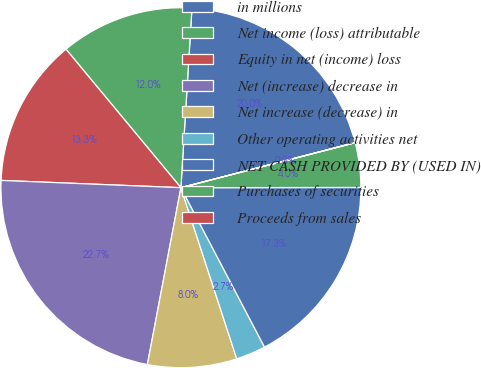<chart> <loc_0><loc_0><loc_500><loc_500><pie_chart><fcel>in millions<fcel>Net income (loss) attributable<fcel>Equity in net (income) loss<fcel>Net (increase) decrease in<fcel>Net increase (decrease) in<fcel>Other operating activities net<fcel>NET CASH PROVIDED BY (USED IN)<fcel>Purchases of securities<fcel>Proceeds from sales<nl><fcel>19.99%<fcel>12.0%<fcel>13.33%<fcel>22.66%<fcel>8.0%<fcel>2.67%<fcel>17.33%<fcel>4.0%<fcel>0.01%<nl></chart> 